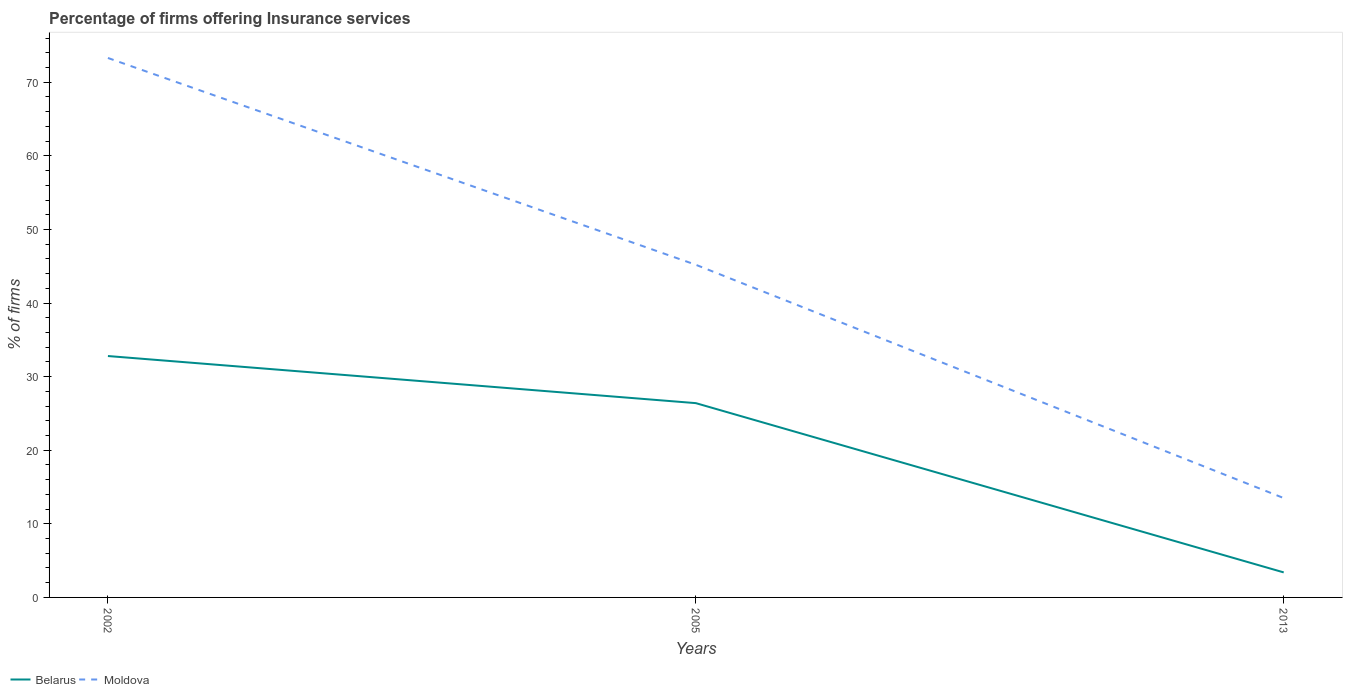How many different coloured lines are there?
Your answer should be very brief. 2. Does the line corresponding to Moldova intersect with the line corresponding to Belarus?
Keep it short and to the point. No. Is the number of lines equal to the number of legend labels?
Your answer should be very brief. Yes. Across all years, what is the maximum percentage of firms offering insurance services in Belarus?
Your answer should be compact. 3.4. What is the total percentage of firms offering insurance services in Moldova in the graph?
Your response must be concise. 31.7. What is the difference between the highest and the second highest percentage of firms offering insurance services in Moldova?
Offer a terse response. 59.8. How many lines are there?
Your answer should be very brief. 2. Are the values on the major ticks of Y-axis written in scientific E-notation?
Your response must be concise. No. Does the graph contain any zero values?
Provide a short and direct response. No. Does the graph contain grids?
Your answer should be compact. No. What is the title of the graph?
Your response must be concise. Percentage of firms offering Insurance services. What is the label or title of the X-axis?
Offer a very short reply. Years. What is the label or title of the Y-axis?
Your response must be concise. % of firms. What is the % of firms of Belarus in 2002?
Ensure brevity in your answer.  32.8. What is the % of firms in Moldova in 2002?
Give a very brief answer. 73.3. What is the % of firms of Belarus in 2005?
Offer a very short reply. 26.4. What is the % of firms of Moldova in 2005?
Make the answer very short. 45.2. What is the % of firms in Belarus in 2013?
Ensure brevity in your answer.  3.4. What is the % of firms in Moldova in 2013?
Offer a very short reply. 13.5. Across all years, what is the maximum % of firms in Belarus?
Offer a very short reply. 32.8. Across all years, what is the maximum % of firms of Moldova?
Make the answer very short. 73.3. Across all years, what is the minimum % of firms of Belarus?
Your response must be concise. 3.4. Across all years, what is the minimum % of firms in Moldova?
Give a very brief answer. 13.5. What is the total % of firms in Belarus in the graph?
Ensure brevity in your answer.  62.6. What is the total % of firms of Moldova in the graph?
Your response must be concise. 132. What is the difference between the % of firms in Moldova in 2002 and that in 2005?
Make the answer very short. 28.1. What is the difference between the % of firms of Belarus in 2002 and that in 2013?
Keep it short and to the point. 29.4. What is the difference between the % of firms of Moldova in 2002 and that in 2013?
Your answer should be very brief. 59.8. What is the difference between the % of firms in Moldova in 2005 and that in 2013?
Offer a very short reply. 31.7. What is the difference between the % of firms in Belarus in 2002 and the % of firms in Moldova in 2005?
Your response must be concise. -12.4. What is the difference between the % of firms in Belarus in 2002 and the % of firms in Moldova in 2013?
Offer a terse response. 19.3. What is the average % of firms of Belarus per year?
Make the answer very short. 20.87. What is the average % of firms of Moldova per year?
Ensure brevity in your answer.  44. In the year 2002, what is the difference between the % of firms of Belarus and % of firms of Moldova?
Give a very brief answer. -40.5. In the year 2005, what is the difference between the % of firms in Belarus and % of firms in Moldova?
Ensure brevity in your answer.  -18.8. What is the ratio of the % of firms in Belarus in 2002 to that in 2005?
Your answer should be compact. 1.24. What is the ratio of the % of firms of Moldova in 2002 to that in 2005?
Offer a very short reply. 1.62. What is the ratio of the % of firms in Belarus in 2002 to that in 2013?
Keep it short and to the point. 9.65. What is the ratio of the % of firms in Moldova in 2002 to that in 2013?
Make the answer very short. 5.43. What is the ratio of the % of firms in Belarus in 2005 to that in 2013?
Ensure brevity in your answer.  7.76. What is the ratio of the % of firms of Moldova in 2005 to that in 2013?
Give a very brief answer. 3.35. What is the difference between the highest and the second highest % of firms in Moldova?
Offer a very short reply. 28.1. What is the difference between the highest and the lowest % of firms of Belarus?
Offer a very short reply. 29.4. What is the difference between the highest and the lowest % of firms of Moldova?
Keep it short and to the point. 59.8. 